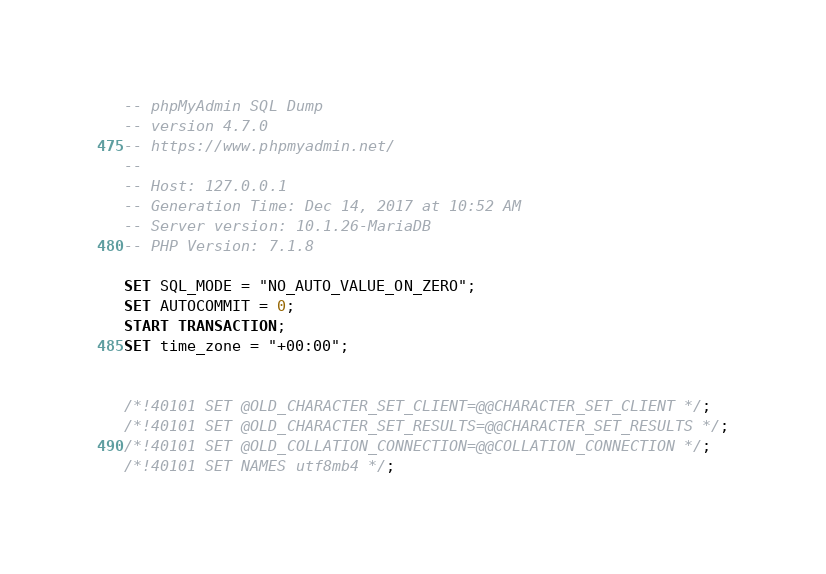Convert code to text. <code><loc_0><loc_0><loc_500><loc_500><_SQL_>-- phpMyAdmin SQL Dump
-- version 4.7.0
-- https://www.phpmyadmin.net/
--
-- Host: 127.0.0.1
-- Generation Time: Dec 14, 2017 at 10:52 AM
-- Server version: 10.1.26-MariaDB
-- PHP Version: 7.1.8

SET SQL_MODE = "NO_AUTO_VALUE_ON_ZERO";
SET AUTOCOMMIT = 0;
START TRANSACTION;
SET time_zone = "+00:00";


/*!40101 SET @OLD_CHARACTER_SET_CLIENT=@@CHARACTER_SET_CLIENT */;
/*!40101 SET @OLD_CHARACTER_SET_RESULTS=@@CHARACTER_SET_RESULTS */;
/*!40101 SET @OLD_COLLATION_CONNECTION=@@COLLATION_CONNECTION */;
/*!40101 SET NAMES utf8mb4 */;
</code> 